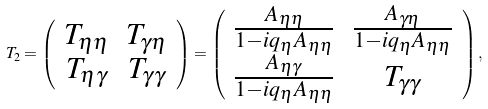Convert formula to latex. <formula><loc_0><loc_0><loc_500><loc_500>T _ { 2 } = \left ( \begin{array} { c c } T _ { \eta \eta } & T _ { \gamma \eta } \\ T _ { \eta \gamma } & T _ { \gamma \gamma } \end{array} \right ) = \left ( \begin{array} { c c } \frac { A _ { \eta \eta } } { 1 - i q _ { \eta } A _ { \eta \eta } } & \frac { A _ { \gamma \eta } } { 1 - i q _ { \eta } A _ { \eta \eta } } \\ \frac { A _ { \eta \gamma } } { 1 - i q _ { \eta } A _ { \eta \eta } } & T _ { \gamma \gamma } \end{array} \right ) ,</formula> 